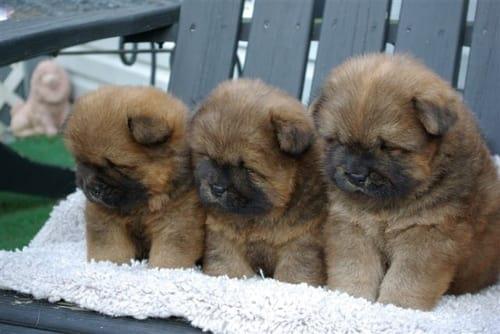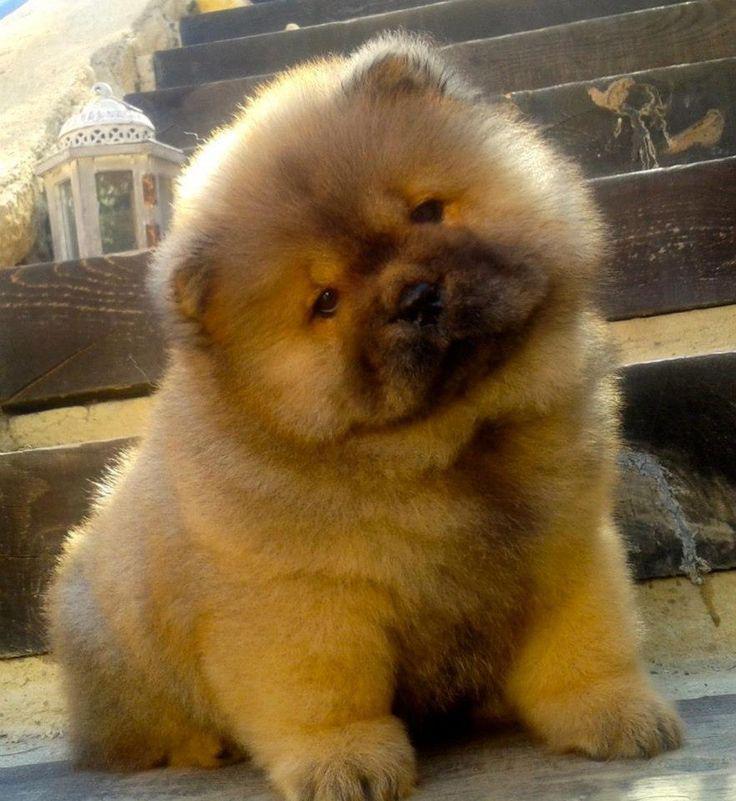The first image is the image on the left, the second image is the image on the right. Analyze the images presented: Is the assertion "Three puppies sit side by side on a white cloth in one image, while a single pup appears in the other image, all with their mouths closed." valid? Answer yes or no. Yes. The first image is the image on the left, the second image is the image on the right. Evaluate the accuracy of this statement regarding the images: "In one of the images there are three puppies sitting in a row.". Is it true? Answer yes or no. Yes. 